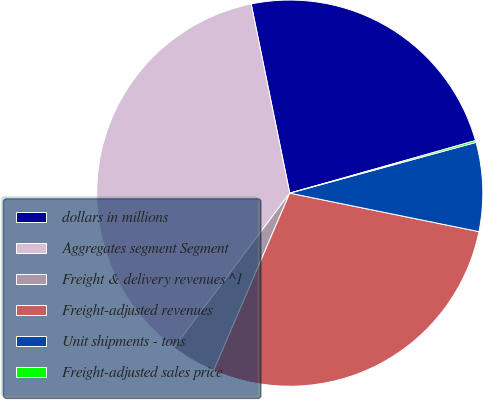Convert chart. <chart><loc_0><loc_0><loc_500><loc_500><pie_chart><fcel>dollars in millions<fcel>Aggregates segment Segment<fcel>Freight & delivery revenues ^1<fcel>Freight-adjusted revenues<fcel>Unit shipments - tons<fcel>Freight-adjusted sales price<nl><fcel>23.81%<fcel>36.55%<fcel>3.79%<fcel>28.25%<fcel>7.43%<fcel>0.15%<nl></chart> 